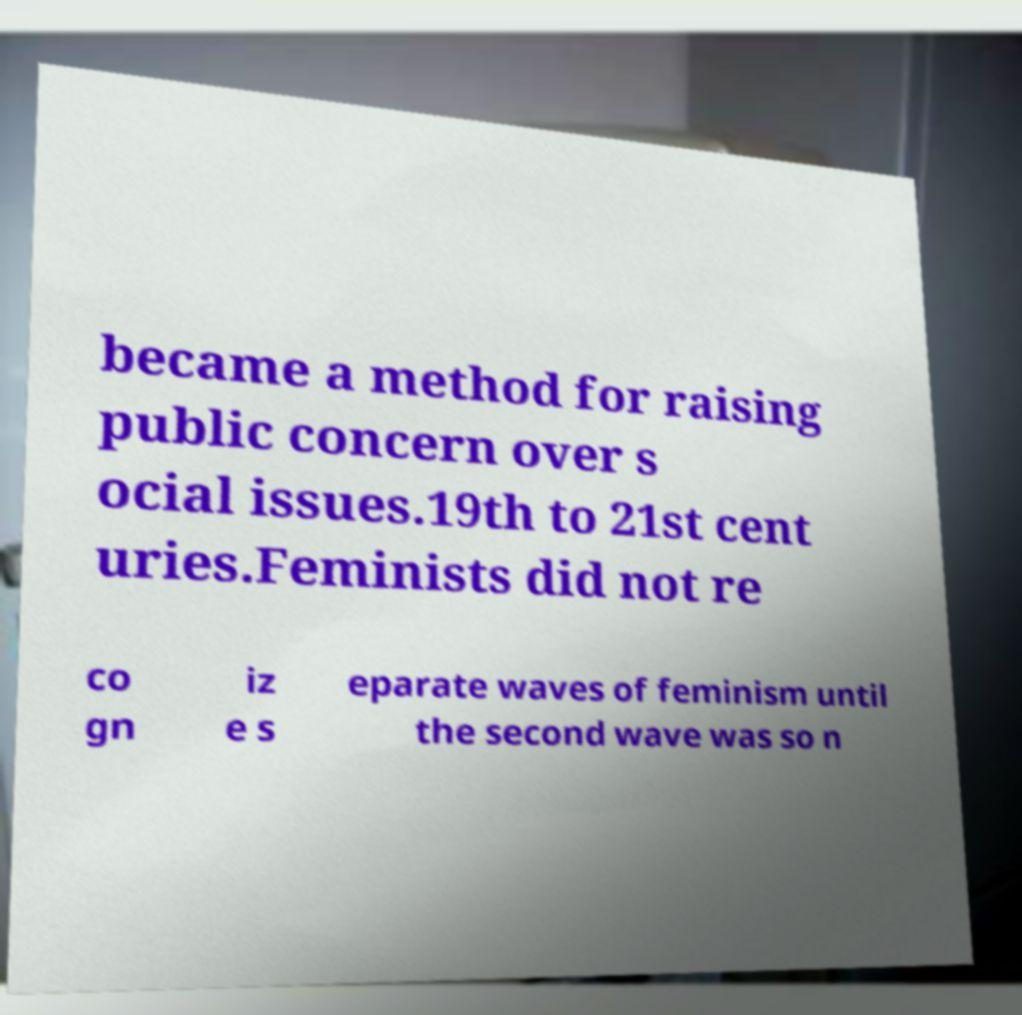I need the written content from this picture converted into text. Can you do that? became a method for raising public concern over s ocial issues.19th to 21st cent uries.Feminists did not re co gn iz e s eparate waves of feminism until the second wave was so n 